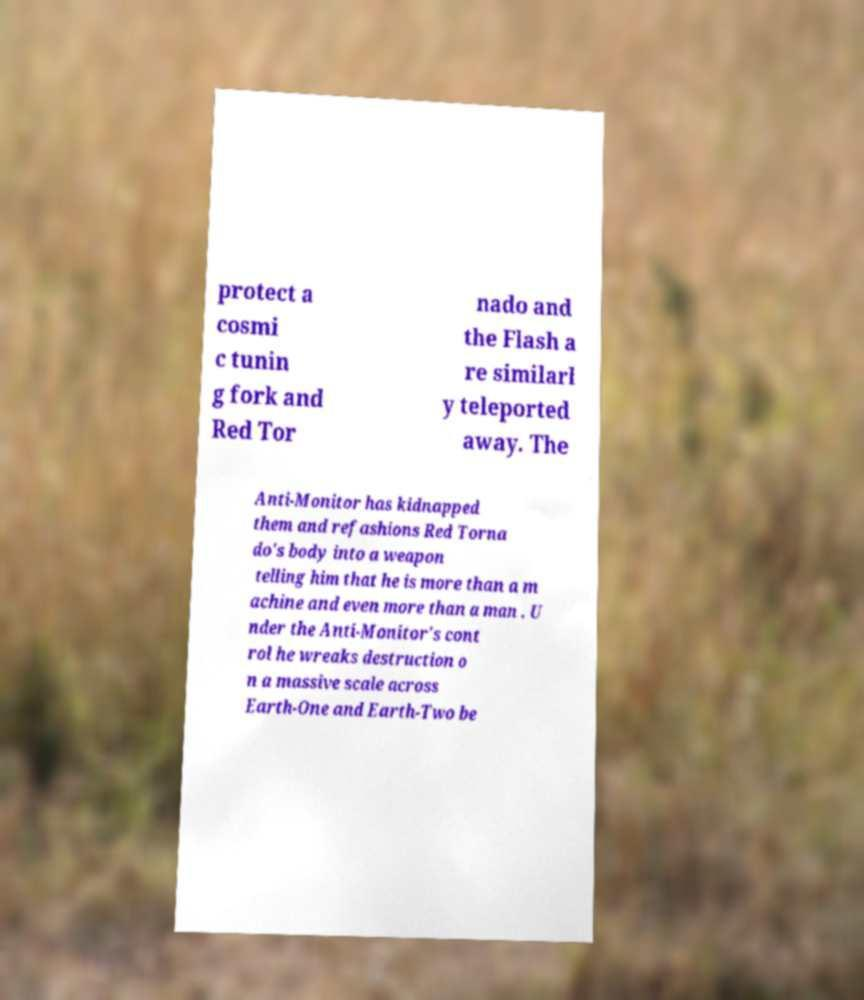There's text embedded in this image that I need extracted. Can you transcribe it verbatim? protect a cosmi c tunin g fork and Red Tor nado and the Flash a re similarl y teleported away. The Anti-Monitor has kidnapped them and refashions Red Torna do's body into a weapon telling him that he is more than a m achine and even more than a man . U nder the Anti-Monitor's cont rol he wreaks destruction o n a massive scale across Earth-One and Earth-Two be 